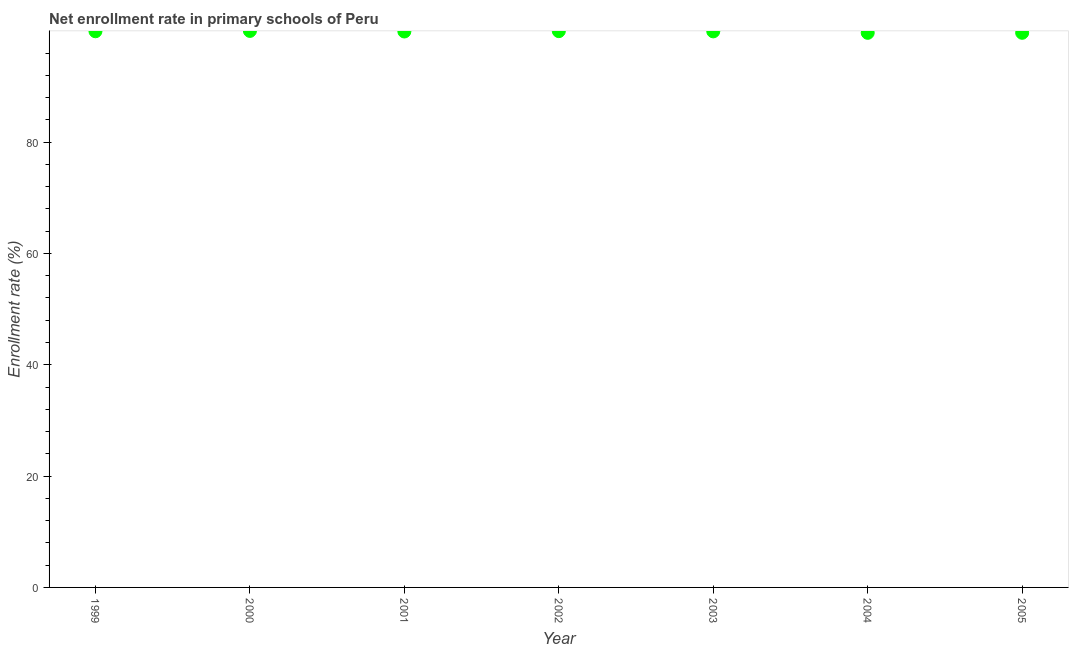What is the net enrollment rate in primary schools in 1999?
Provide a short and direct response. 99.91. Across all years, what is the maximum net enrollment rate in primary schools?
Your answer should be very brief. 99.98. Across all years, what is the minimum net enrollment rate in primary schools?
Offer a terse response. 99.63. In which year was the net enrollment rate in primary schools minimum?
Keep it short and to the point. 2004. What is the sum of the net enrollment rate in primary schools?
Offer a very short reply. 698.86. What is the difference between the net enrollment rate in primary schools in 2000 and 2003?
Give a very brief answer. 0.08. What is the average net enrollment rate in primary schools per year?
Offer a terse response. 99.84. What is the median net enrollment rate in primary schools?
Your answer should be very brief. 99.89. What is the ratio of the net enrollment rate in primary schools in 2000 to that in 2003?
Provide a short and direct response. 1. Is the difference between the net enrollment rate in primary schools in 2003 and 2005 greater than the difference between any two years?
Provide a short and direct response. No. What is the difference between the highest and the second highest net enrollment rate in primary schools?
Make the answer very short. 0.04. Is the sum of the net enrollment rate in primary schools in 1999 and 2002 greater than the maximum net enrollment rate in primary schools across all years?
Offer a terse response. Yes. What is the difference between the highest and the lowest net enrollment rate in primary schools?
Ensure brevity in your answer.  0.34. In how many years, is the net enrollment rate in primary schools greater than the average net enrollment rate in primary schools taken over all years?
Your answer should be very brief. 5. Are the values on the major ticks of Y-axis written in scientific E-notation?
Give a very brief answer. No. Does the graph contain any zero values?
Your answer should be compact. No. Does the graph contain grids?
Offer a terse response. No. What is the title of the graph?
Ensure brevity in your answer.  Net enrollment rate in primary schools of Peru. What is the label or title of the X-axis?
Provide a short and direct response. Year. What is the label or title of the Y-axis?
Ensure brevity in your answer.  Enrollment rate (%). What is the Enrollment rate (%) in 1999?
Your response must be concise. 99.91. What is the Enrollment rate (%) in 2000?
Your answer should be very brief. 99.98. What is the Enrollment rate (%) in 2001?
Your response must be concise. 99.87. What is the Enrollment rate (%) in 2002?
Give a very brief answer. 99.94. What is the Enrollment rate (%) in 2003?
Your answer should be compact. 99.89. What is the Enrollment rate (%) in 2004?
Your response must be concise. 99.63. What is the Enrollment rate (%) in 2005?
Provide a short and direct response. 99.64. What is the difference between the Enrollment rate (%) in 1999 and 2000?
Ensure brevity in your answer.  -0.06. What is the difference between the Enrollment rate (%) in 1999 and 2001?
Provide a short and direct response. 0.04. What is the difference between the Enrollment rate (%) in 1999 and 2002?
Keep it short and to the point. -0.02. What is the difference between the Enrollment rate (%) in 1999 and 2003?
Offer a terse response. 0.02. What is the difference between the Enrollment rate (%) in 1999 and 2004?
Give a very brief answer. 0.28. What is the difference between the Enrollment rate (%) in 1999 and 2005?
Offer a terse response. 0.27. What is the difference between the Enrollment rate (%) in 2000 and 2001?
Provide a succinct answer. 0.1. What is the difference between the Enrollment rate (%) in 2000 and 2002?
Offer a terse response. 0.04. What is the difference between the Enrollment rate (%) in 2000 and 2003?
Give a very brief answer. 0.08. What is the difference between the Enrollment rate (%) in 2000 and 2004?
Your response must be concise. 0.34. What is the difference between the Enrollment rate (%) in 2000 and 2005?
Make the answer very short. 0.34. What is the difference between the Enrollment rate (%) in 2001 and 2002?
Provide a succinct answer. -0.06. What is the difference between the Enrollment rate (%) in 2001 and 2003?
Your answer should be compact. -0.02. What is the difference between the Enrollment rate (%) in 2001 and 2004?
Your answer should be compact. 0.24. What is the difference between the Enrollment rate (%) in 2001 and 2005?
Offer a terse response. 0.23. What is the difference between the Enrollment rate (%) in 2002 and 2003?
Keep it short and to the point. 0.04. What is the difference between the Enrollment rate (%) in 2002 and 2004?
Make the answer very short. 0.3. What is the difference between the Enrollment rate (%) in 2002 and 2005?
Your answer should be very brief. 0.3. What is the difference between the Enrollment rate (%) in 2003 and 2004?
Your response must be concise. 0.26. What is the difference between the Enrollment rate (%) in 2003 and 2005?
Keep it short and to the point. 0.25. What is the difference between the Enrollment rate (%) in 2004 and 2005?
Keep it short and to the point. -0. What is the ratio of the Enrollment rate (%) in 1999 to that in 2001?
Your response must be concise. 1. What is the ratio of the Enrollment rate (%) in 1999 to that in 2002?
Offer a very short reply. 1. What is the ratio of the Enrollment rate (%) in 1999 to that in 2003?
Your answer should be compact. 1. What is the ratio of the Enrollment rate (%) in 2000 to that in 2001?
Give a very brief answer. 1. What is the ratio of the Enrollment rate (%) in 2000 to that in 2004?
Provide a short and direct response. 1. What is the ratio of the Enrollment rate (%) in 2001 to that in 2004?
Give a very brief answer. 1. What is the ratio of the Enrollment rate (%) in 2001 to that in 2005?
Give a very brief answer. 1. What is the ratio of the Enrollment rate (%) in 2002 to that in 2003?
Keep it short and to the point. 1. What is the ratio of the Enrollment rate (%) in 2002 to that in 2005?
Make the answer very short. 1. What is the ratio of the Enrollment rate (%) in 2004 to that in 2005?
Your answer should be very brief. 1. 